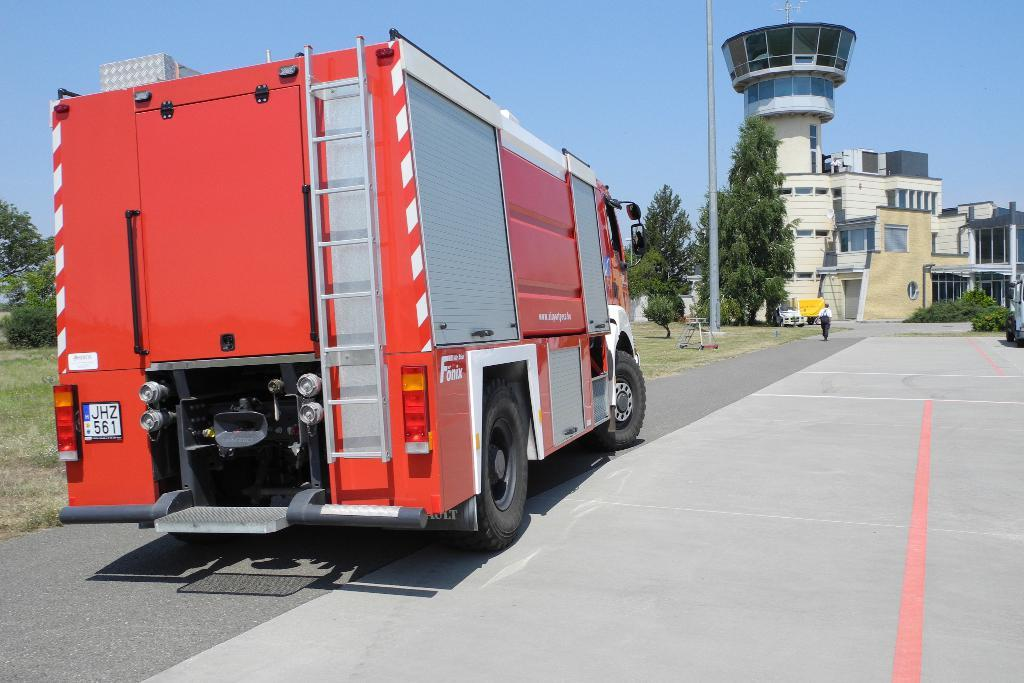What can be seen in the image that moves on roads? There are vehicles in the image that move on roads. What is the person in the image doing? A person is walking on the road in the image. What is located beside the person walking on the road? There is a pole beside the person in the image. What can be seen in the distance in the image? There are trees and buildings in the background of the image. Where is the jail located in the image? There is no jail present in the image. What type of grain is being harvested in the background of the image? There is no grain or harvesting activity present in the image. 